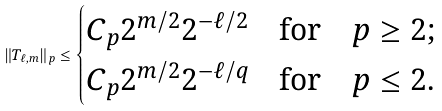Convert formula to latex. <formula><loc_0><loc_0><loc_500><loc_500>\| T _ { \ell , m } \| _ { p } \leq \begin{cases} C _ { p } 2 ^ { m / 2 } 2 ^ { - \ell / 2 } \quad \text {for} \quad p \geq 2 ; \\ C _ { p } 2 ^ { m / 2 } 2 ^ { - \ell / q } \quad \text {for} \quad p \leq 2 . \end{cases}</formula> 